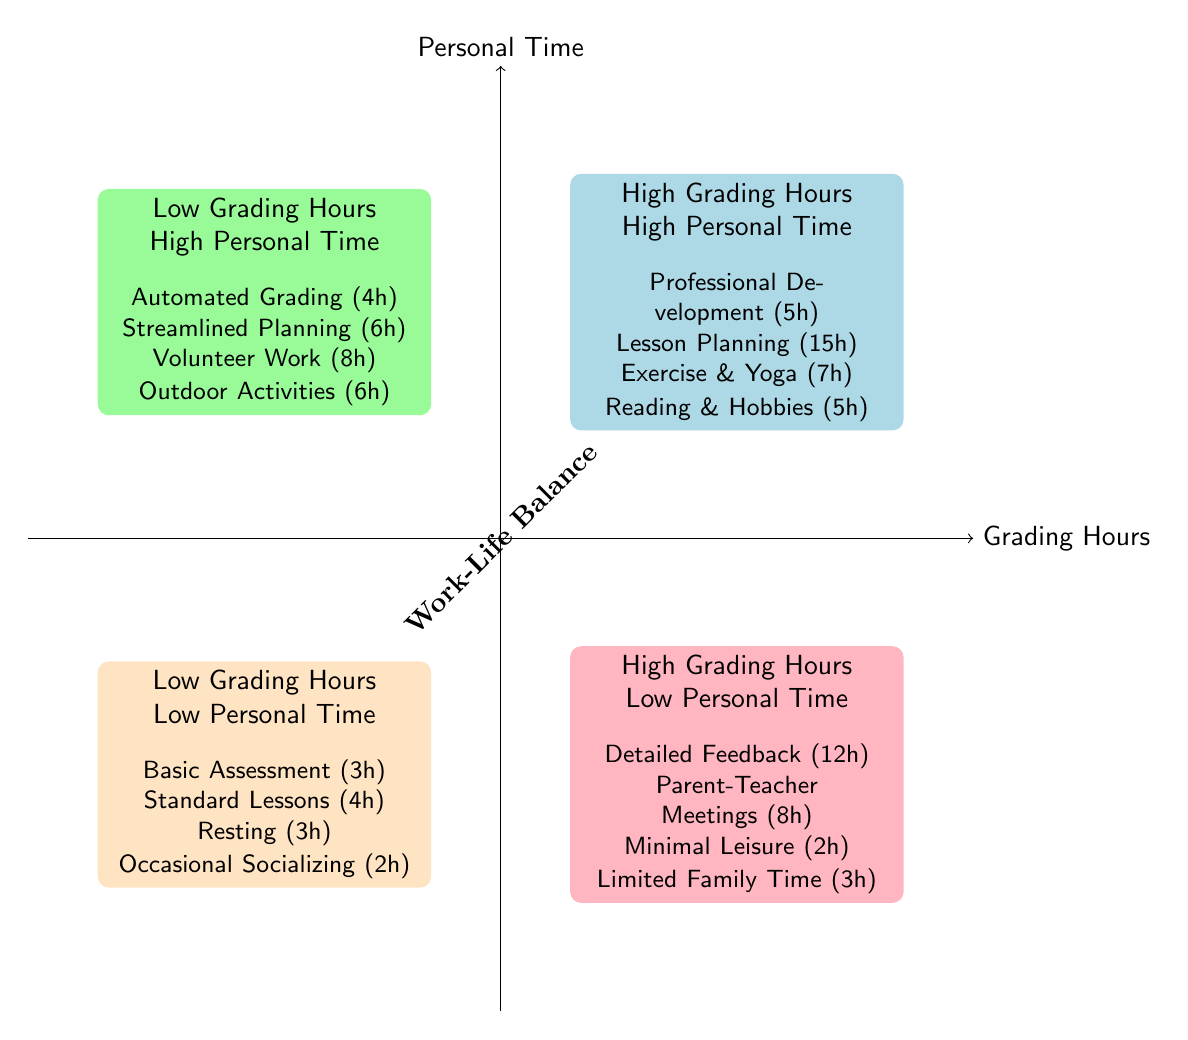What quadrant has high grading hours and high personal time? The quadrant labeled “High Grading Hours - High Personal Time” is located in the top-right section of the diagram.
Answer: High Grading Hours - High Personal Time What activity requires the most hours in the "High Grading Hours - Low Personal Time" quadrant? The activity titled “Detailed Feedback on Assignments” is listed as requiring 12 hours per week, which is the highest in that quadrant.
Answer: Detailed Feedback on Assignments How many hours are dedicated to volunteer work in the "Low Grading Hours - High Personal Time" quadrant? The diagram shows that the “Volunteer Work & Community Engagement” activity requires 8 hours per week in that quadrant.
Answer: 8 Which quadrant indicates a potential risk of burnout for teachers? The quadrant “High Grading Hours - Low Personal Time” suggests minimal personal leisure time, which often leads to burnout.
Answer: High Grading Hours - Low Personal Time What is the total time spent on personal activities in the "Low Grading Hours - Low Personal Time" quadrant? The personal activities listed are “Resting” (3 hours) and “Occasional Socializing” (2 hours), which together account for a total of 5 hours.
Answer: 5 Which activities are present in the "High Grading Hours - High Personal Time" quadrant? The activities listed in that quadrant include “Professional Development Workshops,” “Classroom Management & Lesson Planning,” “Exercise & Yoga,” and “Reading & Hobbies.”
Answer: Professional Development Workshops, Classroom Management & Lesson Planning, Exercise & Yoga, Reading & Hobbies What is the combined grading hours for the "Low Grading Hours - High Personal Time" quadrant? The activities “Automated Grading Tools” (4 hours) and “Streamlined Curriculum Planning” (6 hours) yield a total of 10 grading hours in this quadrant.
Answer: 10 Which quadrant represents the best work-life balance for teachers? The “Low Grading Hours - High Personal Time” quadrant represents a moderate workload with ample personal time, contributing to a better work-life balance.
Answer: Low Grading Hours - High Personal Time 